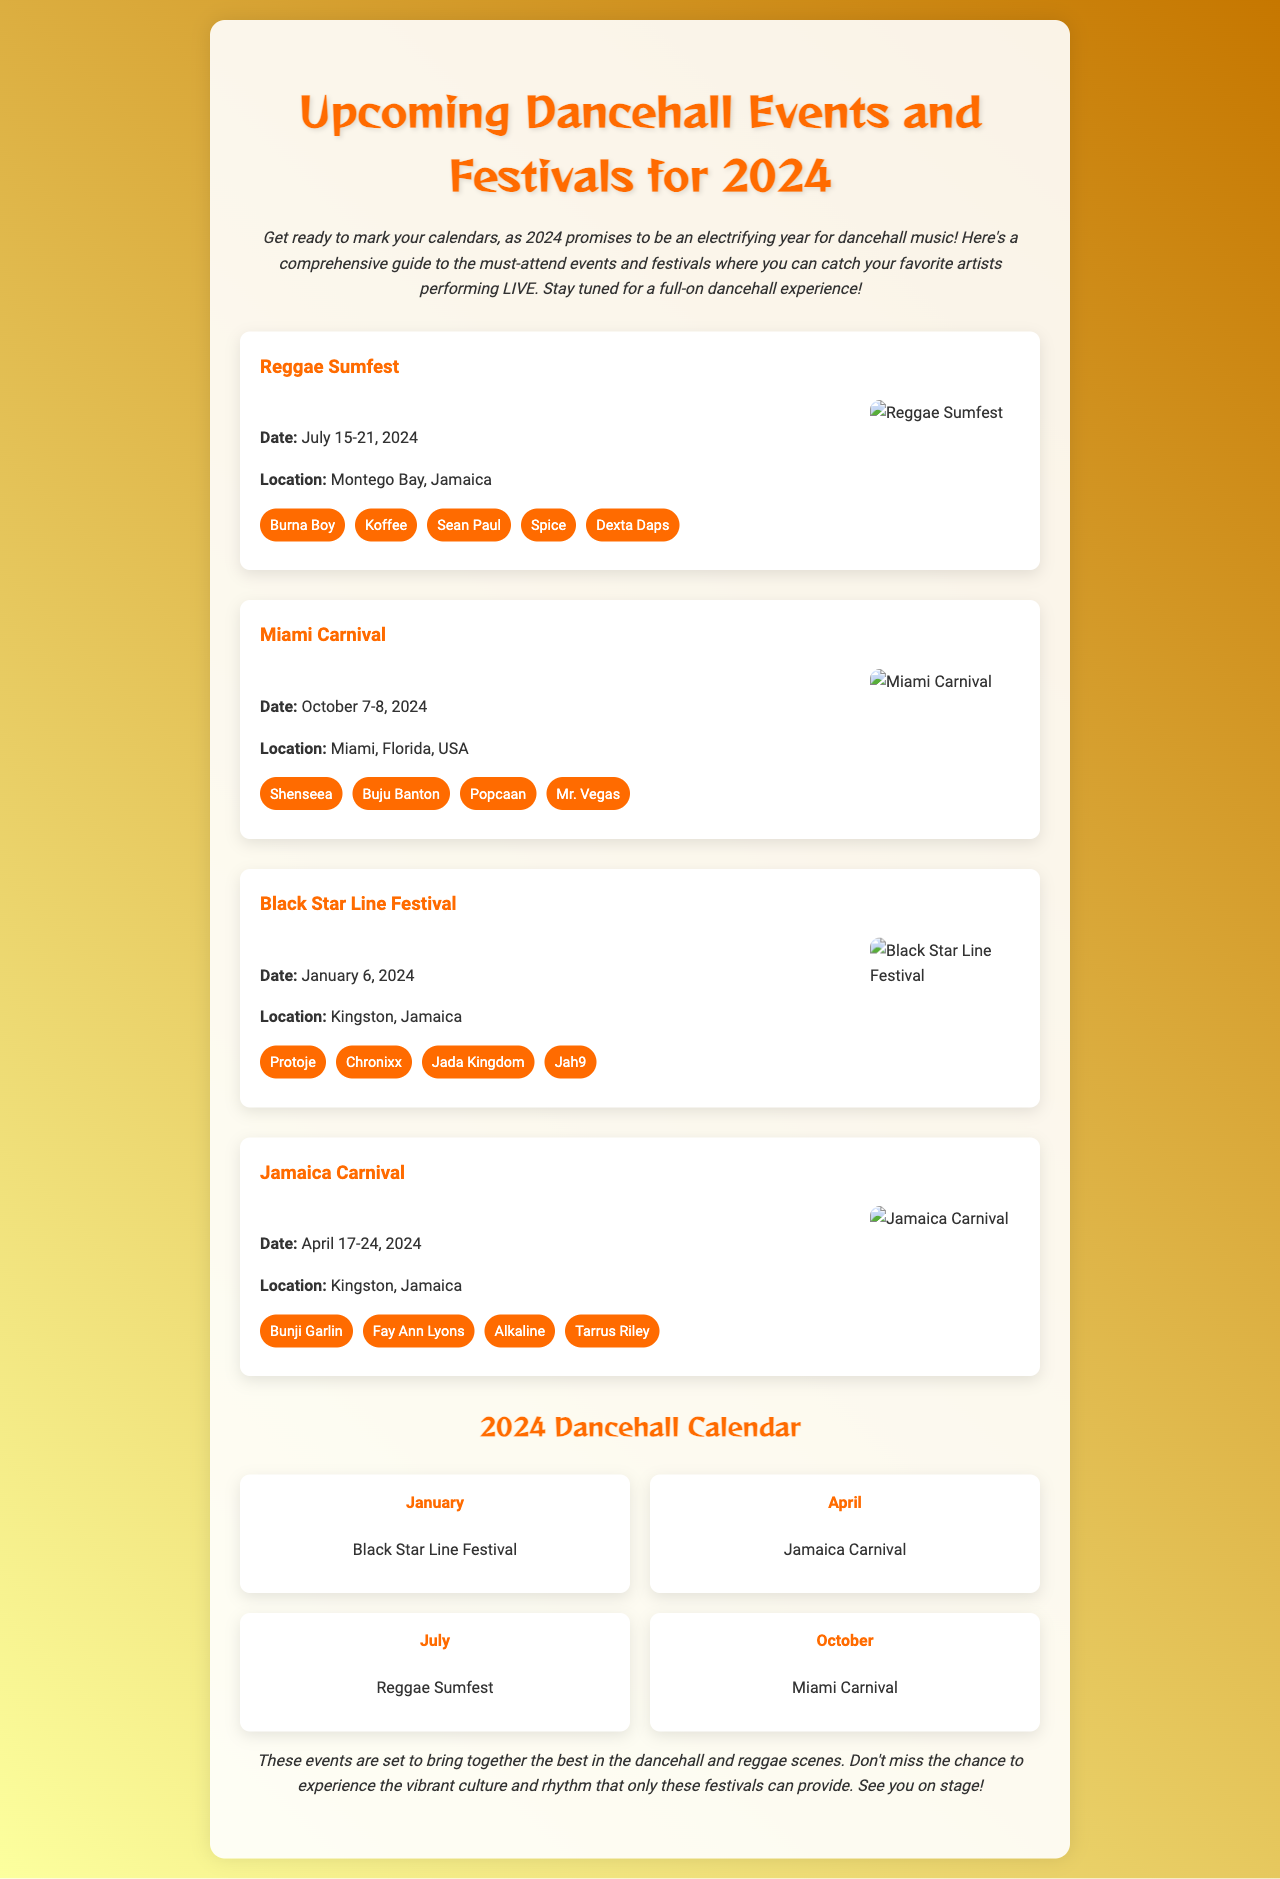What is the date of the Black Star Line Festival? The date is mentioned clearly in the event section for Black Star Line Festival, which states January 6, 2024.
Answer: January 6, 2024 Where is Reggae Sumfest held? The location of Reggae Sumfest is provided in the event details, which states Montego Bay, Jamaica.
Answer: Montego Bay, Jamaica Who is performing at Miami Carnival? The lineup for Miami Carnival includes artists listed under the event details, such as Shenseea, Buju Banton, and Popcaan.
Answer: Shenseea, Buju Banton, Popcaan What month does Jamaica Carnival take place? The document clearly relays that Jamaica Carnival occurs in April, specifically April 17-24, 2024.
Answer: April Which festival happens in July? The events are structured to show their corresponding months, and Reggae Sumfest appears in the July section.
Answer: Reggae Sumfest How many artists are listed for the Jamaica Carnival lineup? The total number of artists can be counted from the event details for Jamaica Carnival, which shows four artists.
Answer: Four What is the main color used in the newsletter's header? The color theme is present in the header section, where the title uses a strong shade of orange (#ff6b00).
Answer: Orange What type of events does the document highlight? The document is focused on a specific genre of music events, emphasizing dancehall events and festivals.
Answer: Dancehall events and festivals 